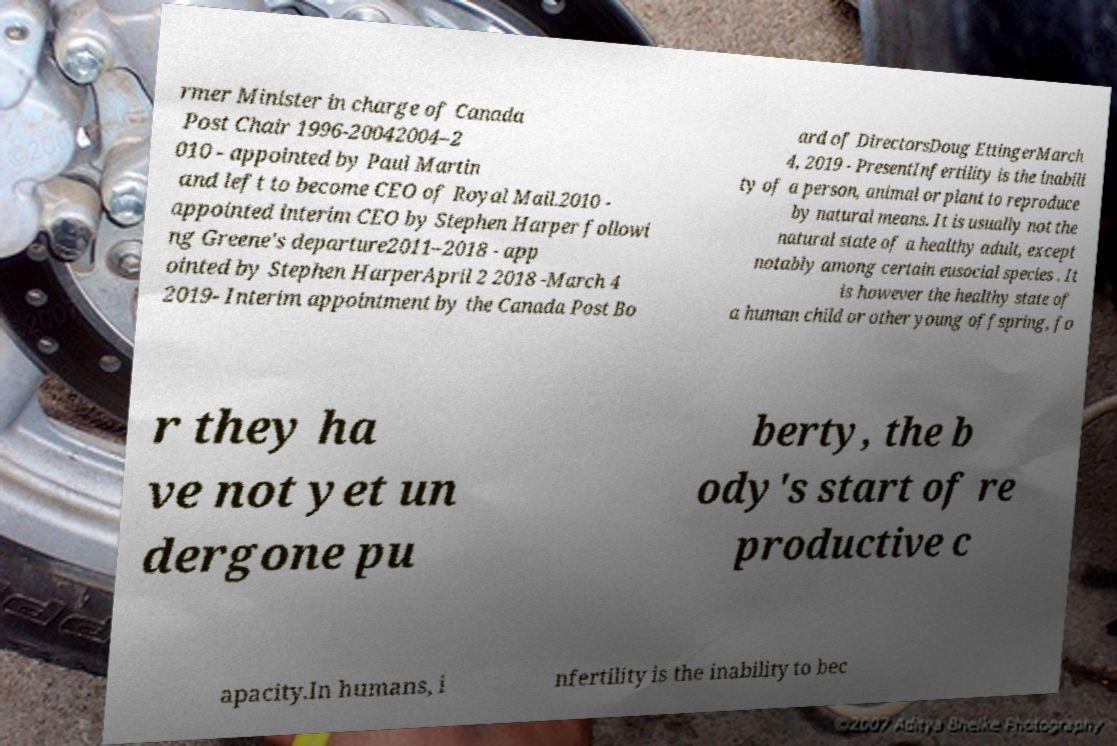What messages or text are displayed in this image? I need them in a readable, typed format. rmer Minister in charge of Canada Post Chair 1996-20042004–2 010 - appointed by Paul Martin and left to become CEO of Royal Mail.2010 - appointed interim CEO by Stephen Harper followi ng Greene's departure2011–2018 - app ointed by Stephen HarperApril 2 2018 -March 4 2019- Interim appointment by the Canada Post Bo ard of DirectorsDoug EttingerMarch 4, 2019 - PresentInfertility is the inabili ty of a person, animal or plant to reproduce by natural means. It is usually not the natural state of a healthy adult, except notably among certain eusocial species . It is however the healthy state of a human child or other young offspring, fo r they ha ve not yet un dergone pu berty, the b ody's start of re productive c apacity.In humans, i nfertility is the inability to bec 